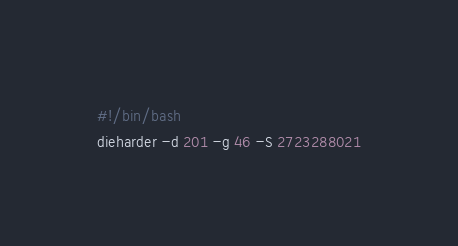<code> <loc_0><loc_0><loc_500><loc_500><_Bash_>#!/bin/bash
dieharder -d 201 -g 46 -S 2723288021
</code> 